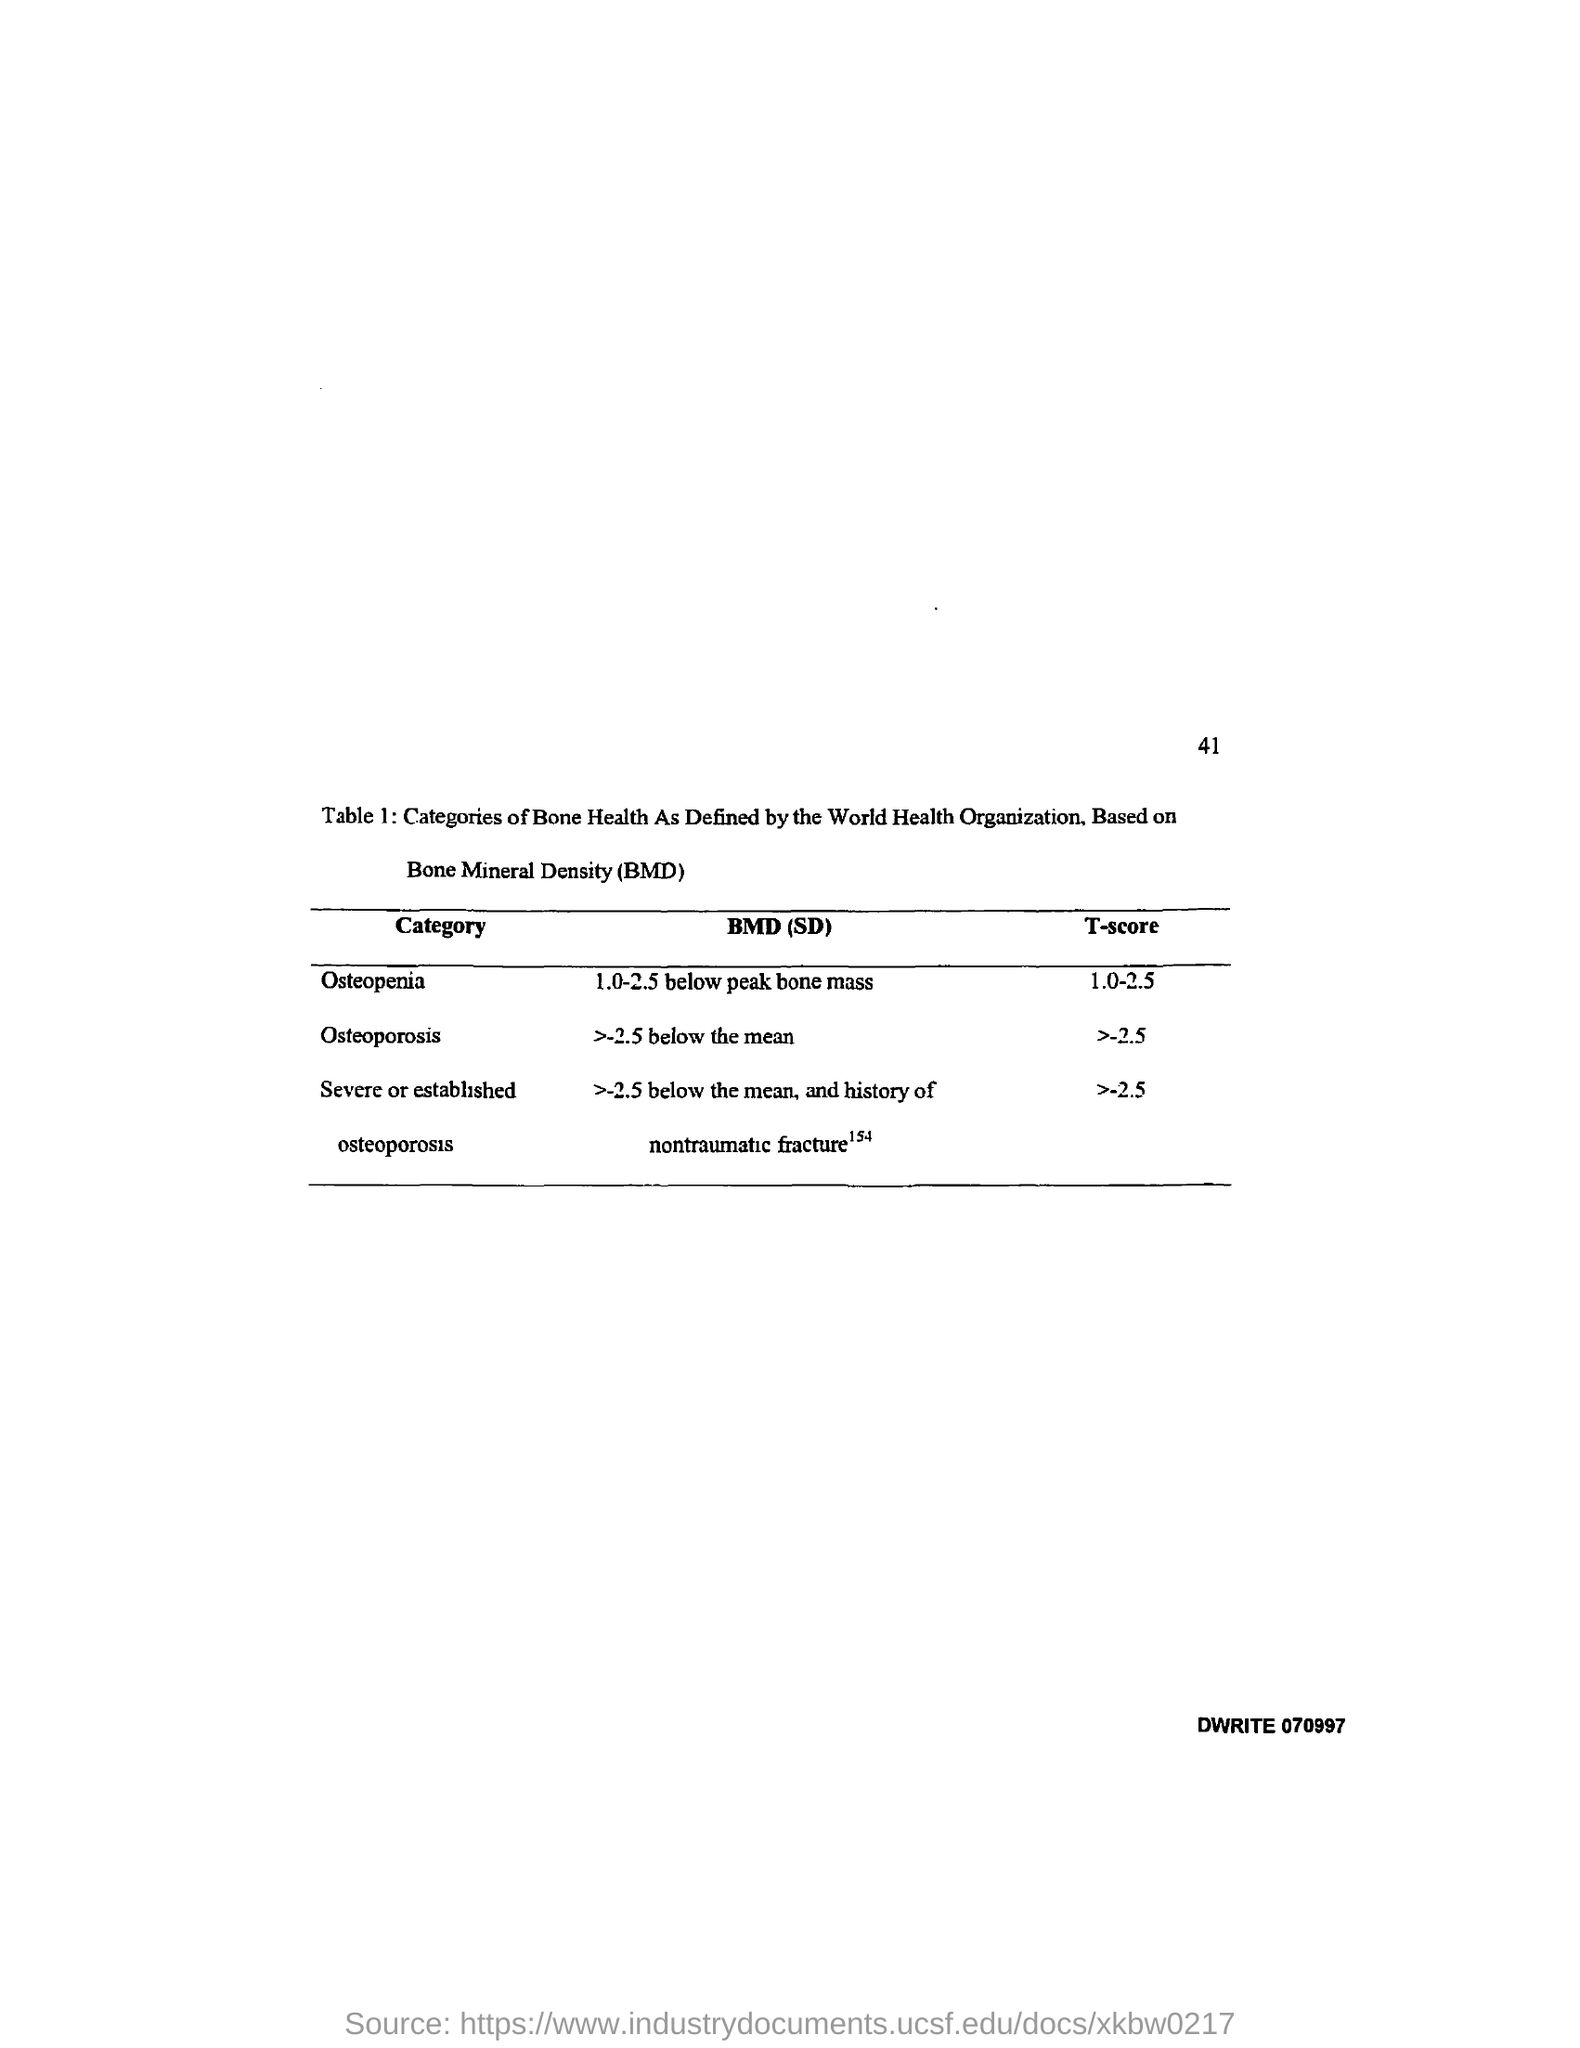What does BMD stand for?
Your response must be concise. Bone Mineral Density. What is the T-score for Osteopenia?
Your answer should be compact. 1.0-2.5. What is the T-score for Osteoporosis?
Your response must be concise. >-2.5. What is the T-score for severe or established osteoporosis?
Offer a terse response. >-2.5. What is the BMD(SD) for Osteopenia?
Offer a terse response. 1.0-2.5 below peak bone mass. What is the BMD(SD) for Osteoporosis?
Your response must be concise. >-2.5 below the mean. 